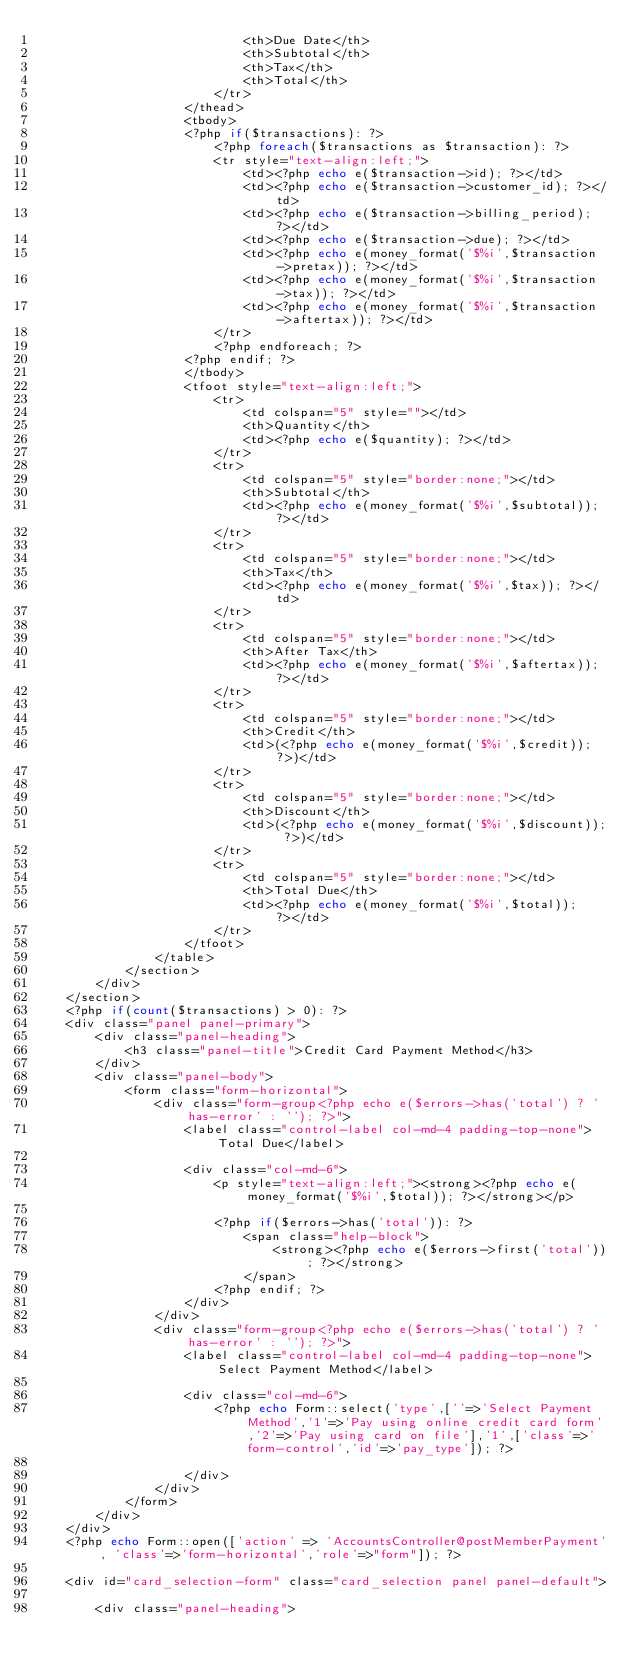Convert code to text. <code><loc_0><loc_0><loc_500><loc_500><_PHP_>							<th>Due Date</th>
							<th>Subtotal</th>
							<th>Tax</th>
							<th>Total</th>
						</tr>
					</thead>
					<tbody>
					<?php if($transactions): ?>
						<?php foreach($transactions as $transaction): ?>
						<tr style="text-align:left;">
							<td><?php echo e($transaction->id); ?></td>
							<td><?php echo e($transaction->customer_id); ?></td>
							<td><?php echo e($transaction->billing_period); ?></td>
							<td><?php echo e($transaction->due); ?></td>
							<td><?php echo e(money_format('$%i',$transaction->pretax)); ?></td>
							<td><?php echo e(money_format('$%i',$transaction->tax)); ?></td>
							<td><?php echo e(money_format('$%i',$transaction->aftertax)); ?></td>
						</tr>
						<?php endforeach; ?>
					<?php endif; ?>
					</tbody>
					<tfoot style="text-align:left;">
						<tr>
							<td colspan="5" style=""></td>
							<th>Quantity</th>
							<td><?php echo e($quantity); ?></td>
						</tr>
						<tr>
							<td colspan="5" style="border:none;"></td>
							<th>Subtotal</th>
							<td><?php echo e(money_format('$%i',$subtotal)); ?></td>
						</tr>
						<tr>
							<td colspan="5" style="border:none;"></td>
							<th>Tax</th>
							<td><?php echo e(money_format('$%i',$tax)); ?></td>
						</tr>
						<tr>
							<td colspan="5" style="border:none;"></td>
							<th>After Tax</th>
							<td><?php echo e(money_format('$%i',$aftertax)); ?></td>
						</tr>
						<tr>
							<td colspan="5" style="border:none;"></td>
							<th>Credit</th>
							<td>(<?php echo e(money_format('$%i',$credit)); ?>)</td>
						</tr>
						<tr>
							<td colspan="5" style="border:none;"></td>
							<th>Discount</th>
							<td>(<?php echo e(money_format('$%i',$discount)); ?>)</td>
						</tr>
						<tr>
							<td colspan="5" style="border:none;"></td>
							<th>Total Due</th>
							<td><?php echo e(money_format('$%i',$total)); ?></td>
						</tr>
					</tfoot>
				</table>
			</section>
		</div>
	</section>
	<?php if(count($transactions) > 0): ?>
	<div class="panel panel-primary">
		<div class="panel-heading">
			<h3 class="panel-title">Credit Card Payment Method</h3>
		</div>
		<div class="panel-body">
			<form class="form-horizontal">
				<div class="form-group<?php echo e($errors->has('total') ? ' has-error' : ''); ?>">
		            <label class="control-label col-md-4 padding-top-none">Total Due</label>

		            <div class="col-md-6">
		            	<p style="text-align:left;"><strong><?php echo e(money_format('$%i',$total)); ?></strong></p>
		               
		                <?php if($errors->has('total')): ?>
		                    <span class="help-block">
		                        <strong><?php echo e($errors->first('total')); ?></strong>
		                    </span>
		                <?php endif; ?>
		            </div>
		        </div>
		        <div class="form-group<?php echo e($errors->has('total') ? ' has-error' : ''); ?>">
		            <label class="control-label col-md-4 padding-top-none">Select Payment Method</label>

		            <div class="col-md-6">
		            	<?php echo Form::select('type',[''=>'Select Payment Method','1'=>'Pay using online credit card form','2'=>'Pay using card on file'],'1',['class'=>'form-control','id'=>'pay_type']); ?>

		            </div>
		        </div>					
			</form>
		</div>
	</div>
	<?php echo Form::open(['action' => 'AccountsController@postMemberPayment', 'class'=>'form-horizontal','role'=>"form"]); ?>

	<div id="card_selection-form" class="card_selection panel panel-default">
		
		<div class="panel-heading"></code> 